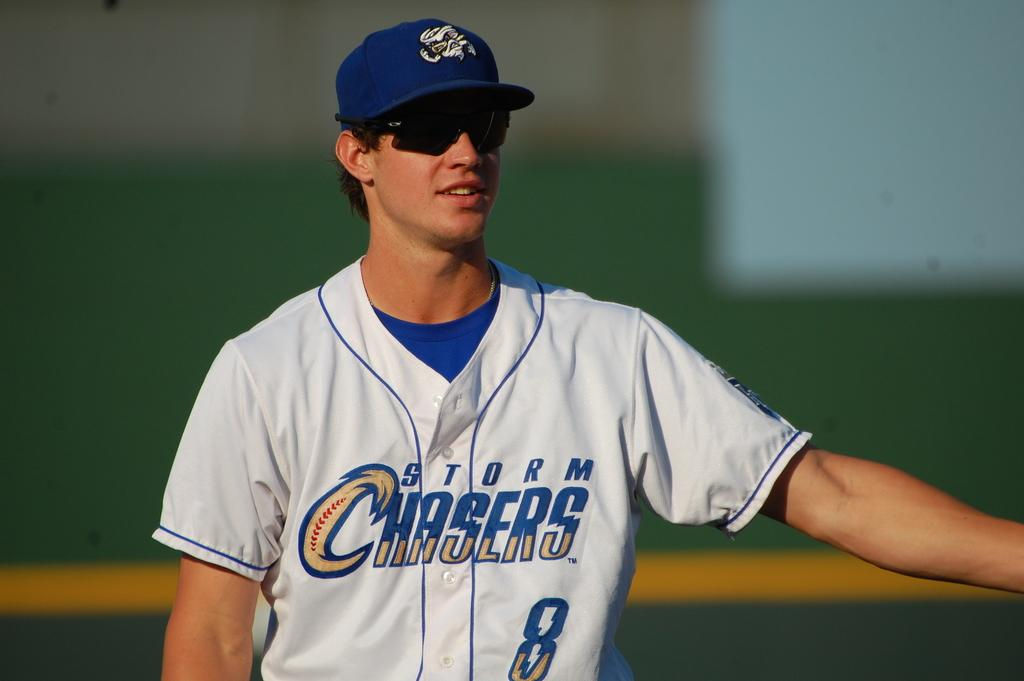<image>
Write a terse but informative summary of the picture. A Storm Chasers baseball player in on-field wearing sun glasses. 